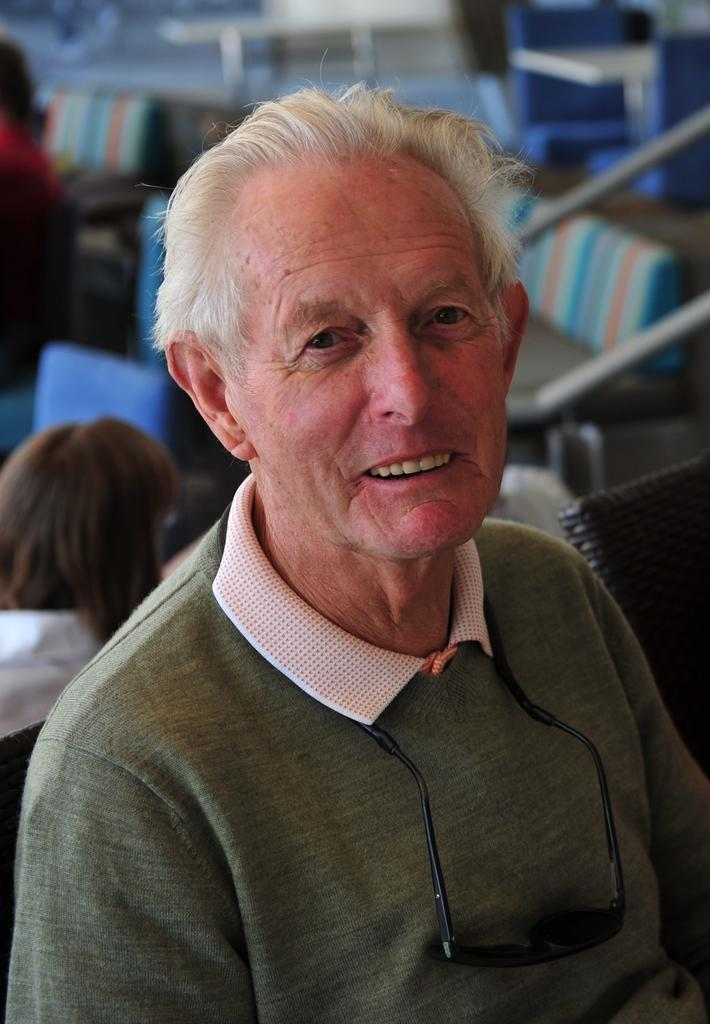Who is present in the image? There is a person in the image. What is the person wearing? The person is wearing a green dress. What is the person doing in the image? The person is sitting. Are there any other people in the image? Yes, there are other people in the image. How many ladybugs can be seen on the person's shirt in the image? There is no mention of a shirt or ladybugs in the image, so it is not possible to answer that question. 